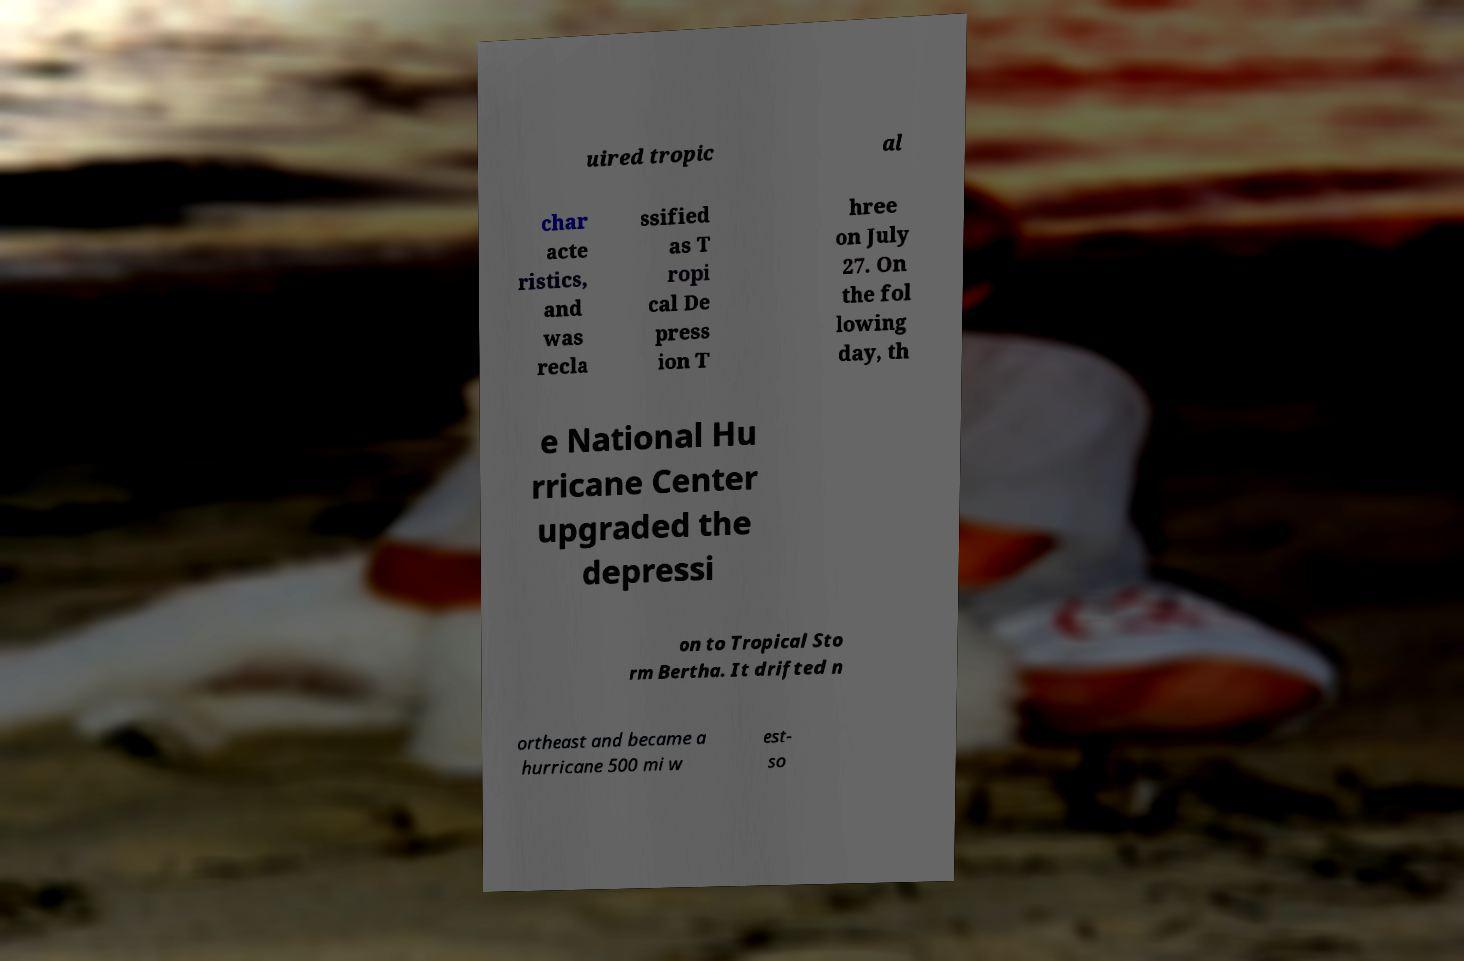Can you read and provide the text displayed in the image?This photo seems to have some interesting text. Can you extract and type it out for me? uired tropic al char acte ristics, and was recla ssified as T ropi cal De press ion T hree on July 27. On the fol lowing day, th e National Hu rricane Center upgraded the depressi on to Tropical Sto rm Bertha. It drifted n ortheast and became a hurricane 500 mi w est- so 